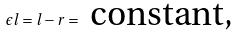Convert formula to latex. <formula><loc_0><loc_0><loc_500><loc_500>\epsilon l = l - r = \text { constant,}</formula> 